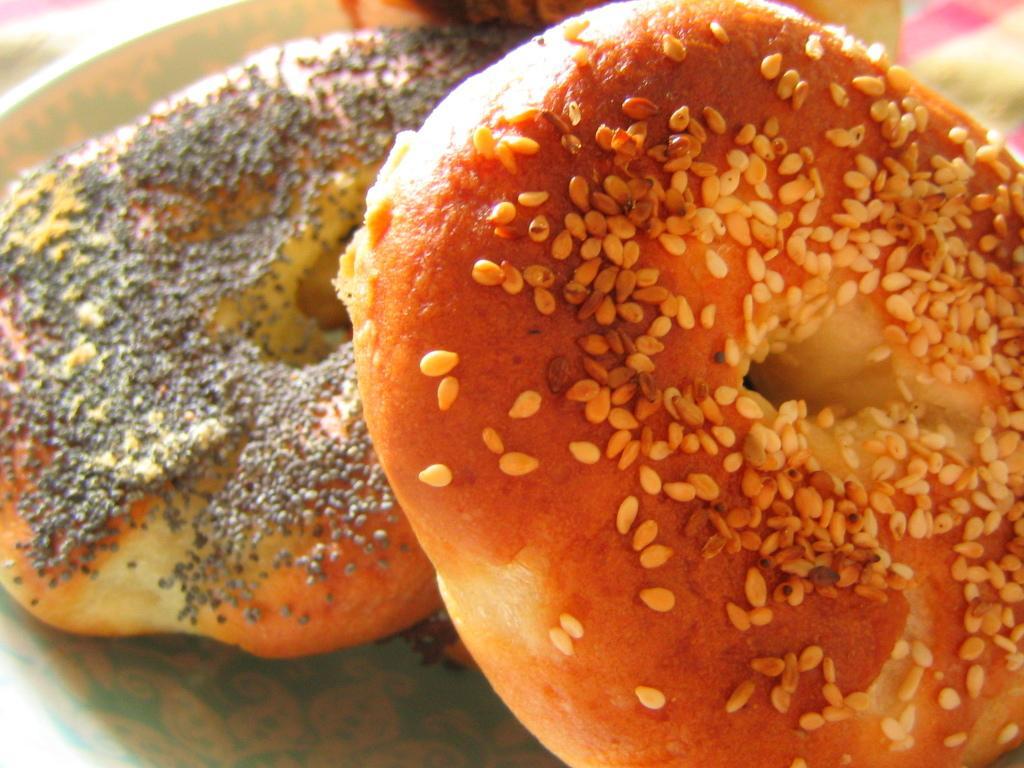Can you describe this image briefly? In this picture I can observe a food item. It is looking like a doughnut. 